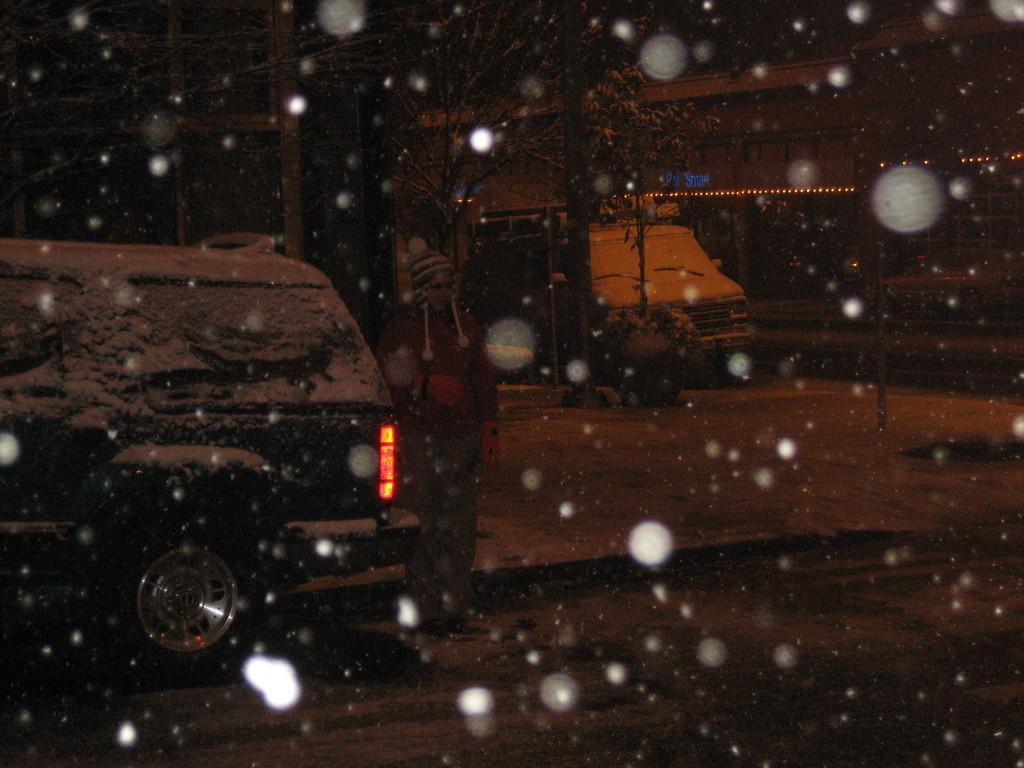What is the lighting condition in the image? The image was taken in the dark. What weather condition is depicted in the image? There is snowfall in the image. How many vehicles can be seen on the road in the image? There are two vehicles on the road in the image. What type of school can be seen in the image? There is no school present in the image. Can you tell me what kind of shop is visible in the image? There is no shop visible in the image. 